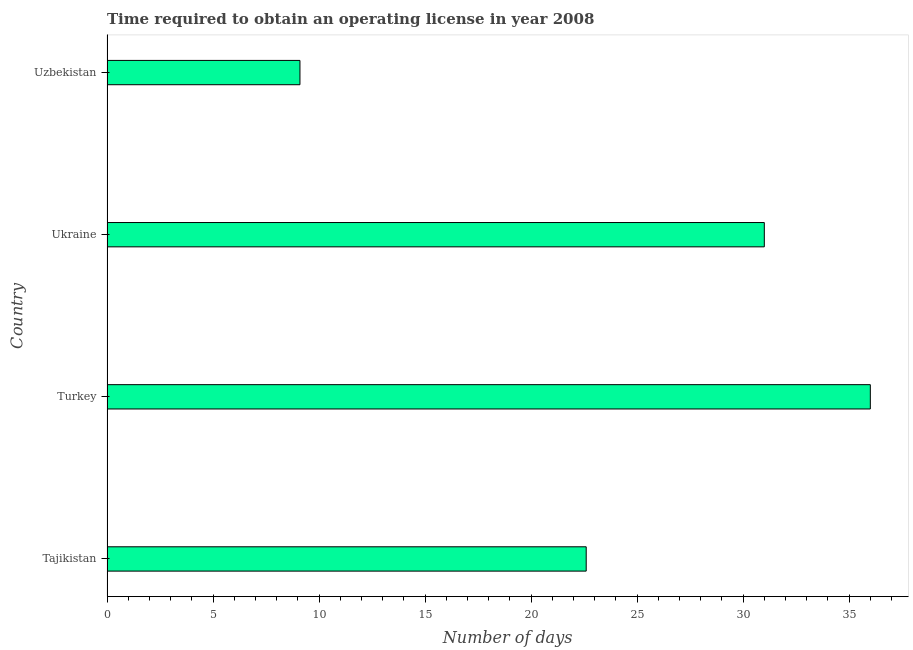What is the title of the graph?
Give a very brief answer. Time required to obtain an operating license in year 2008. What is the label or title of the X-axis?
Ensure brevity in your answer.  Number of days. In which country was the number of days to obtain operating license minimum?
Your answer should be very brief. Uzbekistan. What is the sum of the number of days to obtain operating license?
Give a very brief answer. 98.7. What is the difference between the number of days to obtain operating license in Tajikistan and Turkey?
Offer a terse response. -13.4. What is the average number of days to obtain operating license per country?
Ensure brevity in your answer.  24.68. What is the median number of days to obtain operating license?
Make the answer very short. 26.8. What is the ratio of the number of days to obtain operating license in Turkey to that in Ukraine?
Your answer should be compact. 1.16. Is the number of days to obtain operating license in Tajikistan less than that in Uzbekistan?
Ensure brevity in your answer.  No. What is the difference between the highest and the lowest number of days to obtain operating license?
Provide a short and direct response. 26.9. How many bars are there?
Ensure brevity in your answer.  4. What is the Number of days in Tajikistan?
Give a very brief answer. 22.6. What is the Number of days in Uzbekistan?
Provide a succinct answer. 9.1. What is the difference between the Number of days in Tajikistan and Turkey?
Your response must be concise. -13.4. What is the difference between the Number of days in Tajikistan and Uzbekistan?
Your answer should be compact. 13.5. What is the difference between the Number of days in Turkey and Uzbekistan?
Provide a short and direct response. 26.9. What is the difference between the Number of days in Ukraine and Uzbekistan?
Offer a very short reply. 21.9. What is the ratio of the Number of days in Tajikistan to that in Turkey?
Your response must be concise. 0.63. What is the ratio of the Number of days in Tajikistan to that in Ukraine?
Give a very brief answer. 0.73. What is the ratio of the Number of days in Tajikistan to that in Uzbekistan?
Offer a very short reply. 2.48. What is the ratio of the Number of days in Turkey to that in Ukraine?
Make the answer very short. 1.16. What is the ratio of the Number of days in Turkey to that in Uzbekistan?
Your response must be concise. 3.96. What is the ratio of the Number of days in Ukraine to that in Uzbekistan?
Provide a succinct answer. 3.41. 